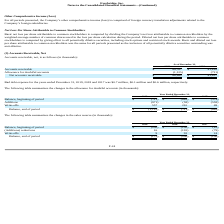According to Everbridge's financial document, How much was the Bad debt expense for the years ended December 31, 2019? According to the financial document, $0.7 million. The relevant text states: "e years ended December 31, 2019, 2018 and 2017 was $0.7 million, $0.1 million and $0.6 million, respectively...." Also, How much was the Bad debt expense for the years ended December 31, 2018? According to the financial document, $0.1 million. The relevant text states: "December 31, 2019, 2018 and 2017 was $0.7 million, $0.1 million and $0.6 million, respectively...." Also, How much was the Bad debt expense for the years ended December 31, 2017? According to the financial document, $0.6 million. The relevant text states: ", 2018 and 2017 was $0.7 million, $0.1 million and $0.6 million, respectively...." Also, can you calculate: What is the change in Accounts receivable from December 31, 2019 to December 31, 2018? Based on the calculation: 69,767-41,818, the result is 27949 (in thousands). This is based on the information: "Accounts receivable $ 69,767 $ 41,818 Accounts receivable $ 69,767 $ 41,818..." The key data points involved are: 41,818, 69,767. Also, can you calculate: What is the change in Allowance for doubtful accounts from December 31, 2019 to December 31, 2018? Based on the calculation: 1,125-711, the result is 414 (in thousands). This is based on the information: "Allowance for doubtful accounts (1,125) (711) Allowance for doubtful accounts (1,125) (711)..." The key data points involved are: 1,125, 711. Also, can you calculate: What is the change in Net accounts receivable from December 31, 2019 to December 31, 2018? Based on the calculation: 68,642-41,107, the result is 27535 (in thousands). This is based on the information: "Net accounts receivable $ 68,642 $ 41,107 Net accounts receivable $ 68,642 $ 41,107..." The key data points involved are: 41,107, 68,642. 